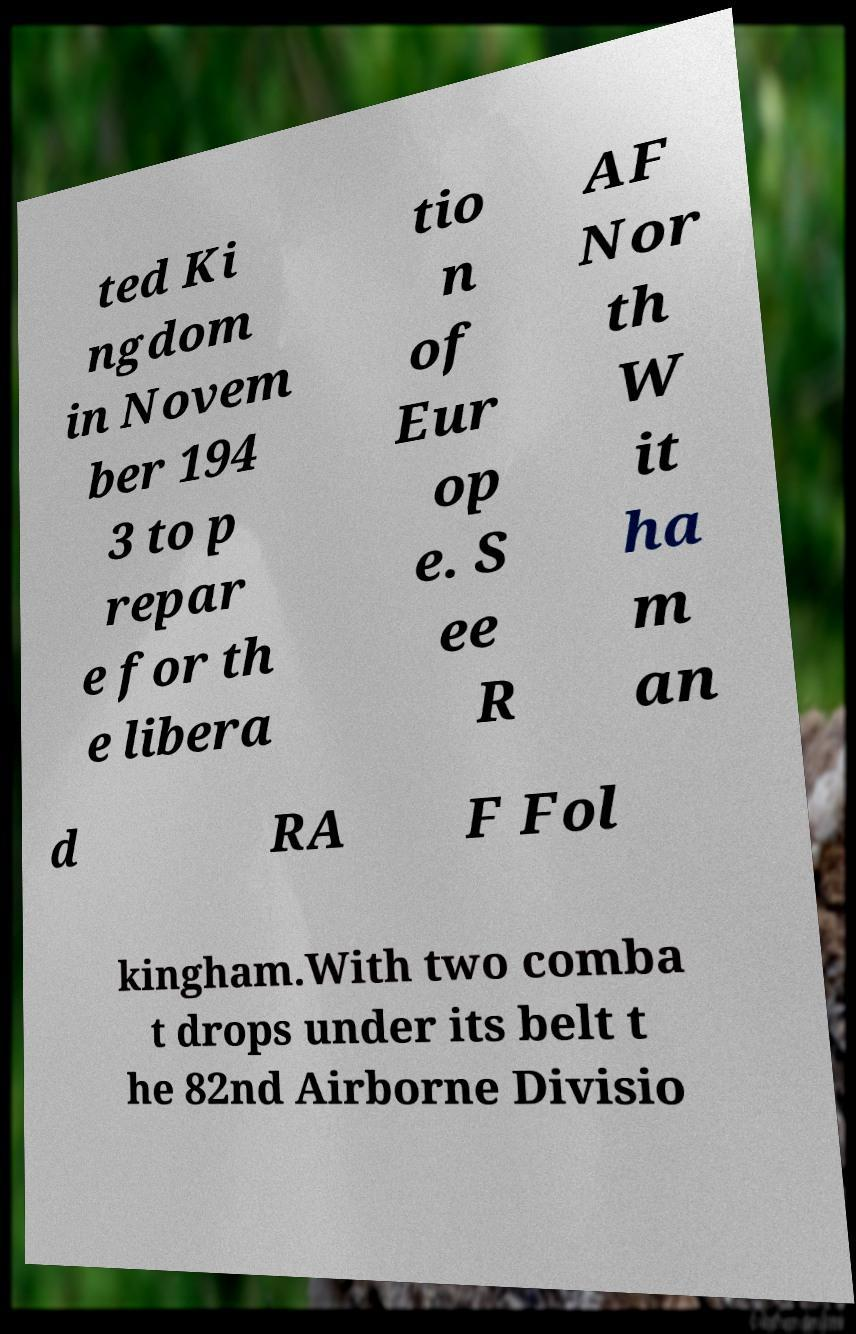I need the written content from this picture converted into text. Can you do that? ted Ki ngdom in Novem ber 194 3 to p repar e for th e libera tio n of Eur op e. S ee R AF Nor th W it ha m an d RA F Fol kingham.With two comba t drops under its belt t he 82nd Airborne Divisio 